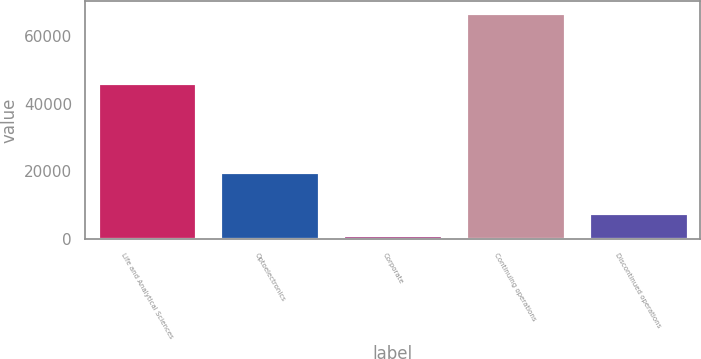Convert chart to OTSL. <chart><loc_0><loc_0><loc_500><loc_500><bar_chart><fcel>Life and Analytical Sciences<fcel>Optoelectronics<fcel>Corporate<fcel>Continuing operations<fcel>Discontinued operations<nl><fcel>46217<fcel>19712<fcel>1069<fcel>66998<fcel>7661.9<nl></chart> 